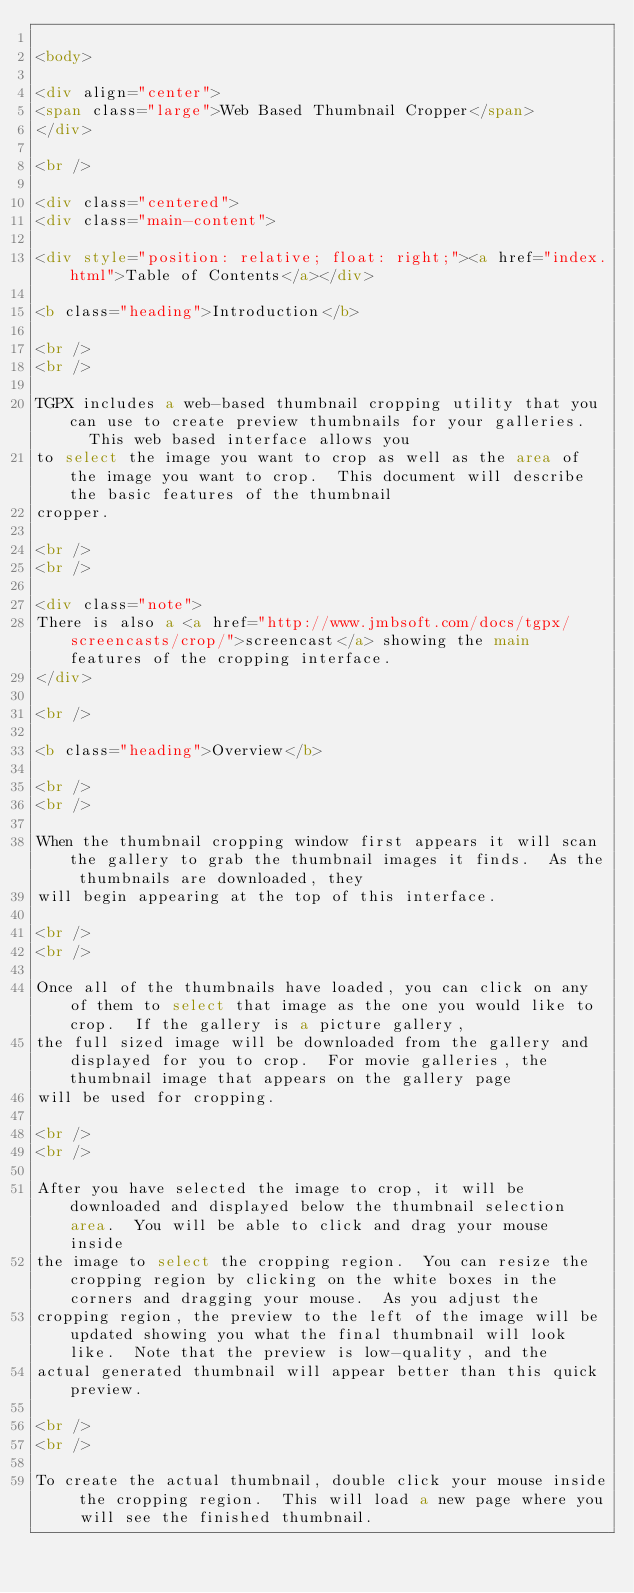Convert code to text. <code><loc_0><loc_0><loc_500><loc_500><_HTML_>
<body>

<div align="center">
<span class="large">Web Based Thumbnail Cropper</span>
</div>

<br />

<div class="centered">
<div class="main-content">

<div style="position: relative; float: right;"><a href="index.html">Table of Contents</a></div>

<b class="heading">Introduction</b>

<br />
<br />

TGPX includes a web-based thumbnail cropping utility that you can use to create preview thumbnails for your galleries.   This web based interface allows you
to select the image you want to crop as well as the area of the image you want to crop.  This document will describe the basic features of the thumbnail
cropper.

<br />
<br />

<div class="note">
There is also a <a href="http://www.jmbsoft.com/docs/tgpx/screencasts/crop/">screencast</a> showing the main features of the cropping interface.
</div>

<br />

<b class="heading">Overview</b>

<br />
<br />

When the thumbnail cropping window first appears it will scan the gallery to grab the thumbnail images it finds.  As the thumbnails are downloaded, they
will begin appearing at the top of this interface.

<br />
<br />

Once all of the thumbnails have loaded, you can click on any of them to select that image as the one you would like to crop.  If the gallery is a picture gallery,
the full sized image will be downloaded from the gallery and displayed for you to crop.  For movie galleries, the thumbnail image that appears on the gallery page
will be used for cropping.

<br />
<br />

After you have selected the image to crop, it will be downloaded and displayed below the thumbnail selection area.  You will be able to click and drag your mouse inside
the image to select the cropping region.  You can resize the cropping region by clicking on the white boxes in the corners and dragging your mouse.  As you adjust the
cropping region, the preview to the left of the image will be updated showing you what the final thumbnail will look like.  Note that the preview is low-quality, and the
actual generated thumbnail will appear better than this quick preview.

<br />
<br />

To create the actual thumbnail, double click your mouse inside the cropping region.  This will load a new page where you will see the finished thumbnail.
</code> 